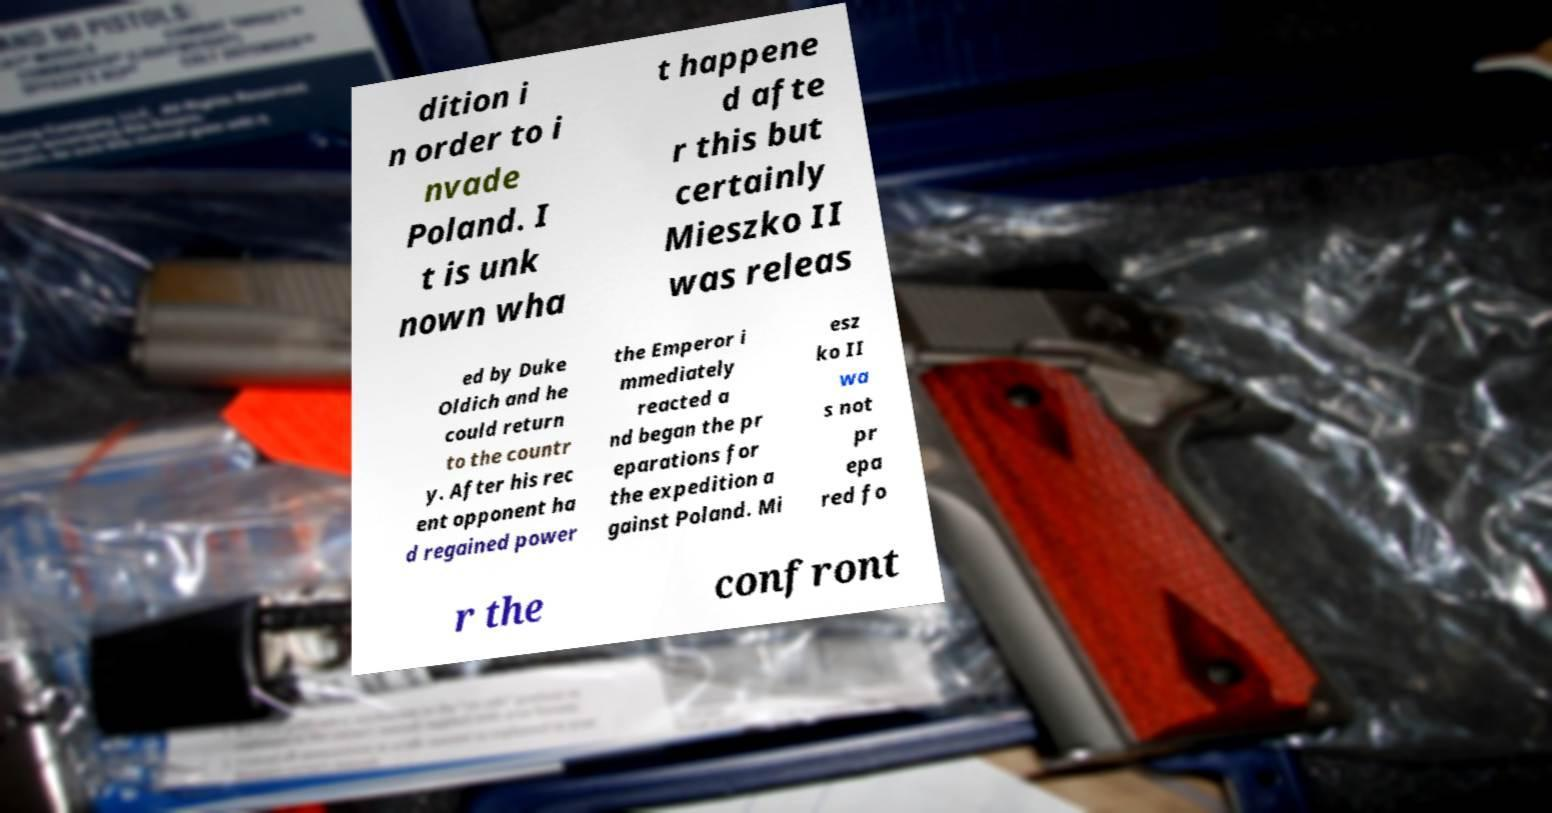Could you extract and type out the text from this image? dition i n order to i nvade Poland. I t is unk nown wha t happene d afte r this but certainly Mieszko II was releas ed by Duke Oldich and he could return to the countr y. After his rec ent opponent ha d regained power the Emperor i mmediately reacted a nd began the pr eparations for the expedition a gainst Poland. Mi esz ko II wa s not pr epa red fo r the confront 